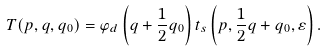<formula> <loc_0><loc_0><loc_500><loc_500>T ( { p } , { q } , { q _ { 0 } } ) = \varphi _ { d } \left ( { q } + \frac { 1 } { 2 } { q } _ { 0 } \right ) t _ { s } \left ( { p } , \frac { 1 } { 2 } { q } + { q } _ { 0 } , \varepsilon \right ) .</formula> 